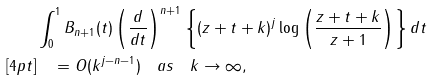Convert formula to latex. <formula><loc_0><loc_0><loc_500><loc_500>& \int _ { 0 } ^ { 1 } B _ { n + 1 } ( t ) \left ( \frac { d } { d t } \right ) ^ { n + 1 } \left \{ ( z + t + k ) ^ { j } \log \left ( \frac { z + t + k } { z + 1 } \right ) \right \} d t \\ [ 4 p t ] & \quad = O ( k ^ { j - n - 1 } ) \quad a s \quad k \to \infty ,</formula> 